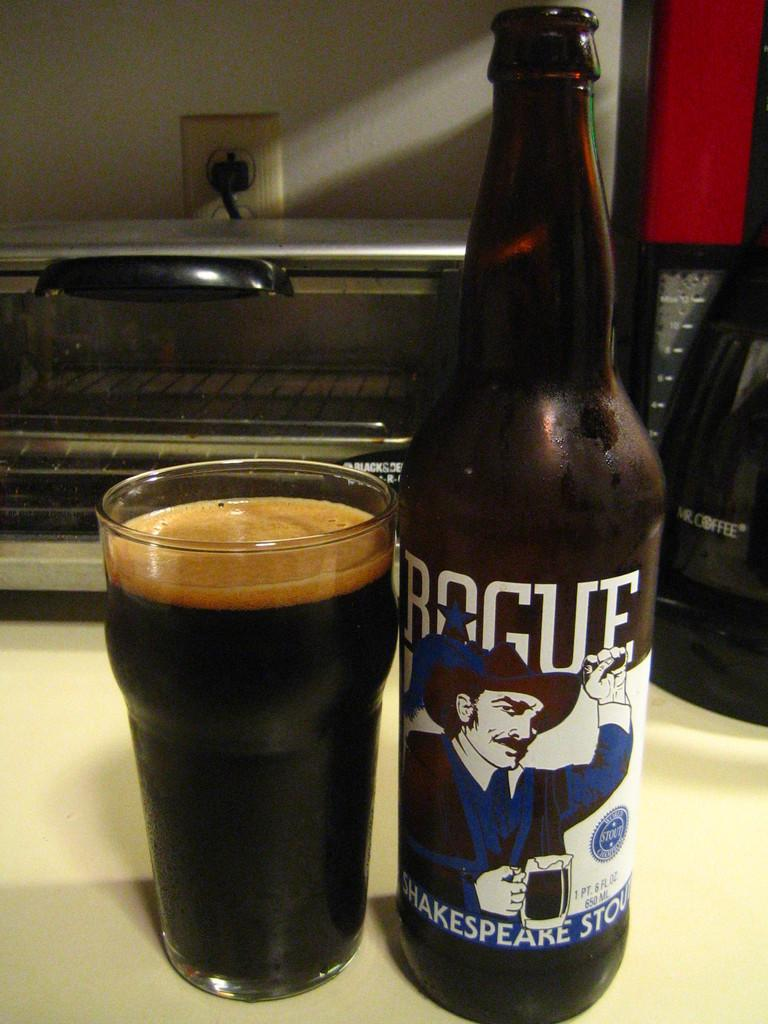<image>
Render a clear and concise summary of the photo. A glass of Rouge poured next to it's bottle on a kitchen counter top. 